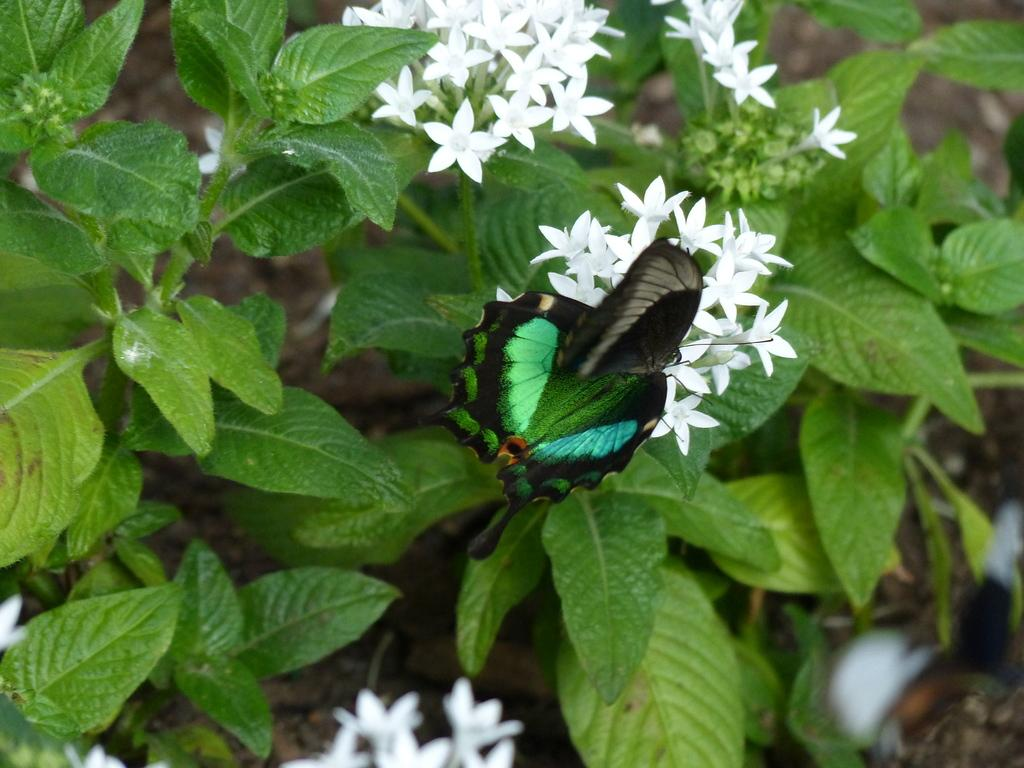What type of plants are in the image? There are flowers on stems in the image. Are there any animals or insects in the image? Yes, there is a butterfly on the flowers in the image. What type of vessel is visible in the image? There is no vessel present in the image. Is there a bridge in the image? There is no bridge present in the image. 